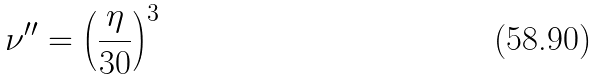<formula> <loc_0><loc_0><loc_500><loc_500>\nu ^ { \prime \prime } = \left ( \frac { \eta } { 3 0 } \right ) ^ { 3 }</formula> 